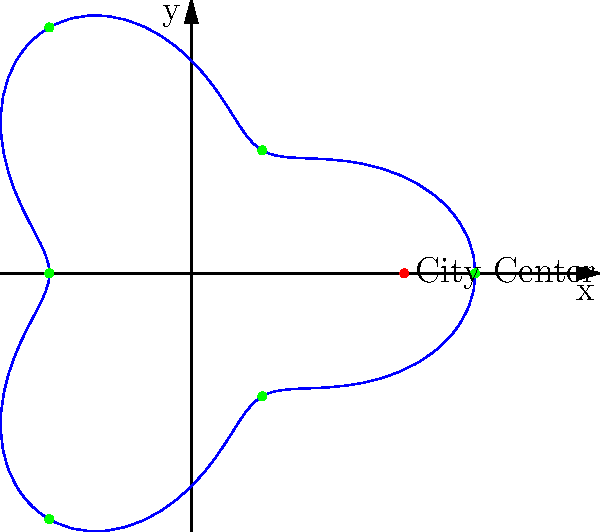A circular bus route for disabled passengers is modeled by the polar equation $r = 3 + \cos(3\theta)$, where $r$ is in kilometers. The route passes through six equidistant stations (green dots) and the city center (red dot). What is the total length of the bus route to the nearest kilometer? To find the length of the bus route, we need to calculate the arc length of the polar curve over one complete revolution. The formula for arc length in polar coordinates is:

$$L = \int_{0}^{2\pi} \sqrt{r^2 + \left(\frac{dr}{d\theta}\right)^2} d\theta$$

For our equation $r = 3 + \cos(3\theta)$:

1) First, we calculate $\frac{dr}{d\theta}$:
   $$\frac{dr}{d\theta} = -3\sin(3\theta)$$

2) Now, we substitute these into the arc length formula:
   $$L = \int_{0}^{2\pi} \sqrt{(3 + \cos(3\theta))^2 + (-3\sin(3\theta))^2} d\theta$$

3) Simplify under the square root:
   $$L = \int_{0}^{2\pi} \sqrt{9 + 6\cos(3\theta) + \cos^2(3\theta) + 9\sin^2(3\theta)} d\theta$$

4) Use the identity $\sin^2(x) + \cos^2(x) = 1$:
   $$L = \int_{0}^{2\pi} \sqrt{18 + 6\cos(3\theta)} d\theta$$

5) This integral cannot be solved analytically. We need to use numerical integration methods to approximate the result.

6) Using a numerical integration tool, we find that:
   $$L \approx 20.71 \text{ km}$$

7) Rounding to the nearest kilometer:
   $$L \approx 21 \text{ km}$$
Answer: 21 km 